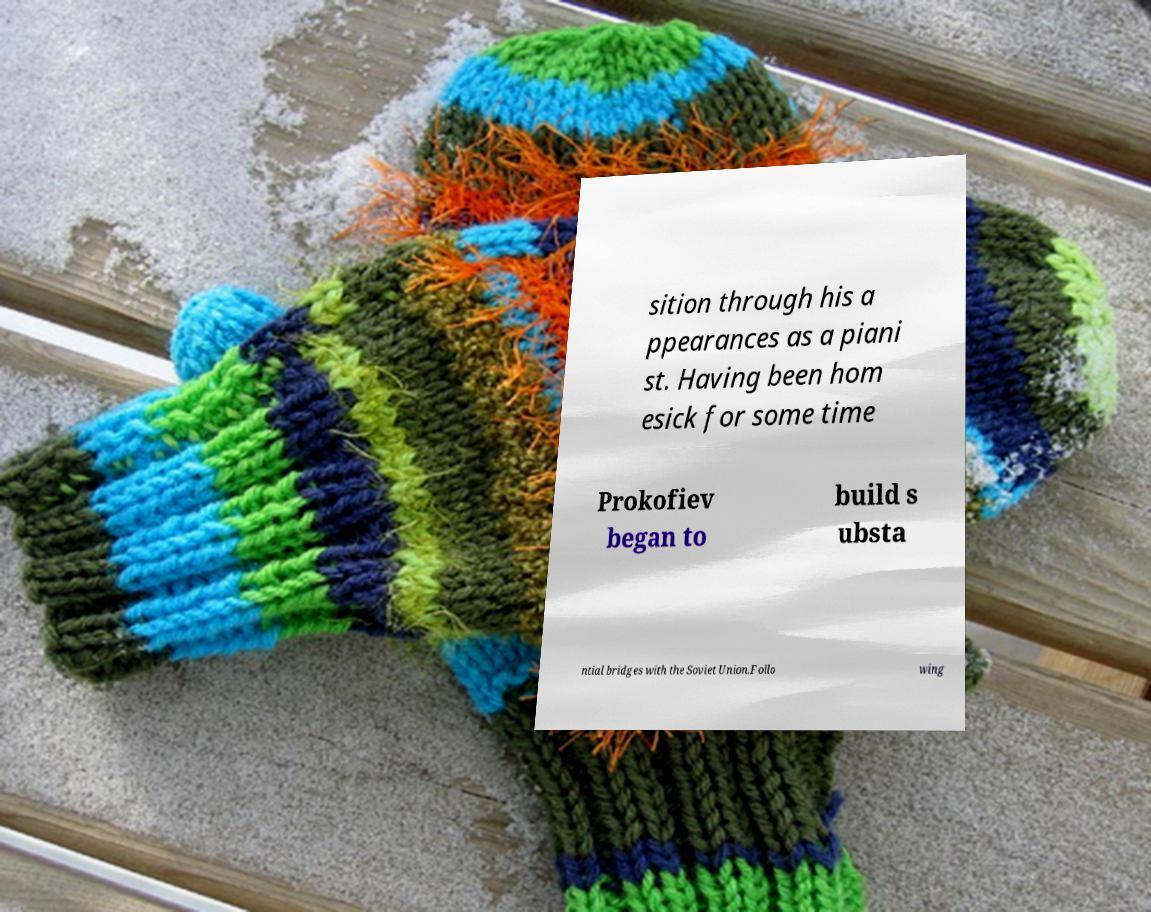Could you extract and type out the text from this image? sition through his a ppearances as a piani st. Having been hom esick for some time Prokofiev began to build s ubsta ntial bridges with the Soviet Union.Follo wing 